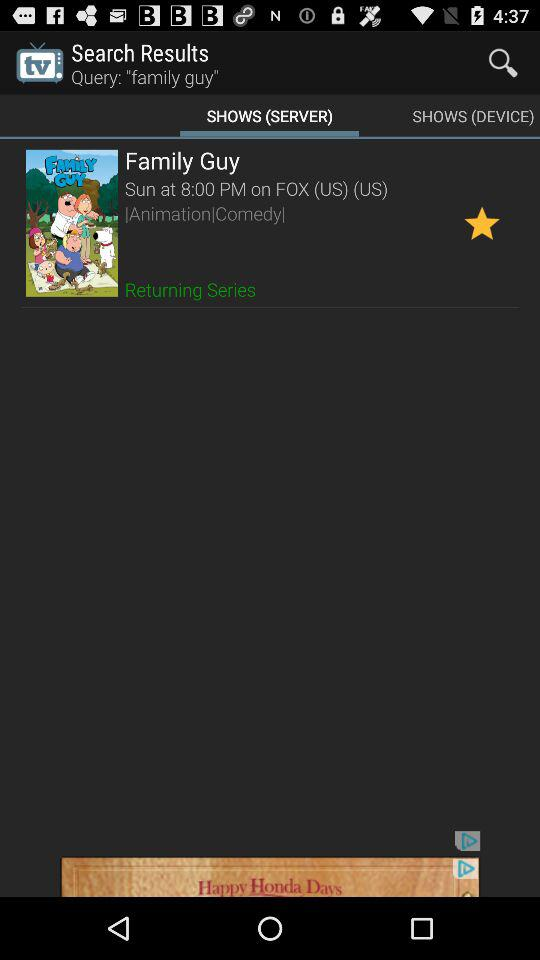Which tab am I on? You are on the "SHOWS (SERVER)" tab. 